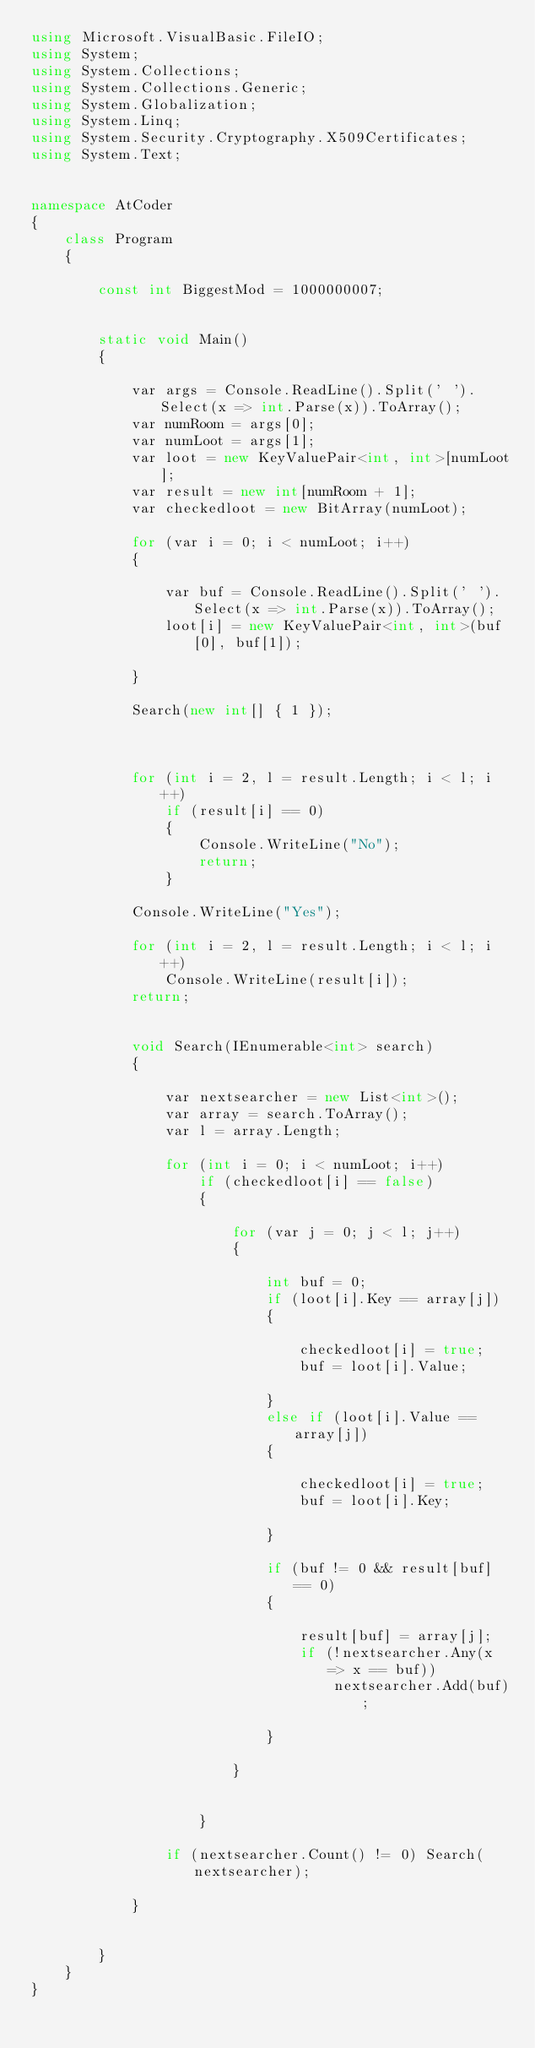<code> <loc_0><loc_0><loc_500><loc_500><_C#_>using Microsoft.VisualBasic.FileIO;
using System;
using System.Collections;
using System.Collections.Generic;
using System.Globalization;
using System.Linq;
using System.Security.Cryptography.X509Certificates;
using System.Text;


namespace AtCoder
{
    class Program
    {

        const int BiggestMod = 1000000007;


        static void Main()
        {

            var args = Console.ReadLine().Split(' ').Select(x => int.Parse(x)).ToArray();
            var numRoom = args[0];
            var numLoot = args[1];
            var loot = new KeyValuePair<int, int>[numLoot];
            var result = new int[numRoom + 1];
            var checkedloot = new BitArray(numLoot);

            for (var i = 0; i < numLoot; i++)
            {

                var buf = Console.ReadLine().Split(' ').Select(x => int.Parse(x)).ToArray();
                loot[i] = new KeyValuePair<int, int>(buf[0], buf[1]);

            }

            Search(new int[] { 1 });



            for (int i = 2, l = result.Length; i < l; i++)
                if (result[i] == 0)
                {
                    Console.WriteLine("No");
                    return;
                }

            Console.WriteLine("Yes");

            for (int i = 2, l = result.Length; i < l; i++)
                Console.WriteLine(result[i]);
            return;


            void Search(IEnumerable<int> search)
            {

                var nextsearcher = new List<int>();
                var array = search.ToArray();
                var l = array.Length;

                for (int i = 0; i < numLoot; i++)
                    if (checkedloot[i] == false)
                    {

                        for (var j = 0; j < l; j++)
                        {

                            int buf = 0;
                            if (loot[i].Key == array[j])
                            {

                                checkedloot[i] = true;
                                buf = loot[i].Value;

                            }
                            else if (loot[i].Value == array[j])
                            {

                                checkedloot[i] = true;
                                buf = loot[i].Key;

                            }

                            if (buf != 0 && result[buf] == 0)
                            {

                                result[buf] = array[j];
                                if (!nextsearcher.Any(x => x == buf))
                                    nextsearcher.Add(buf);

                            }

                        }


                    }

                if (nextsearcher.Count() != 0) Search(nextsearcher);

            }
                

        }
    }
}
</code> 